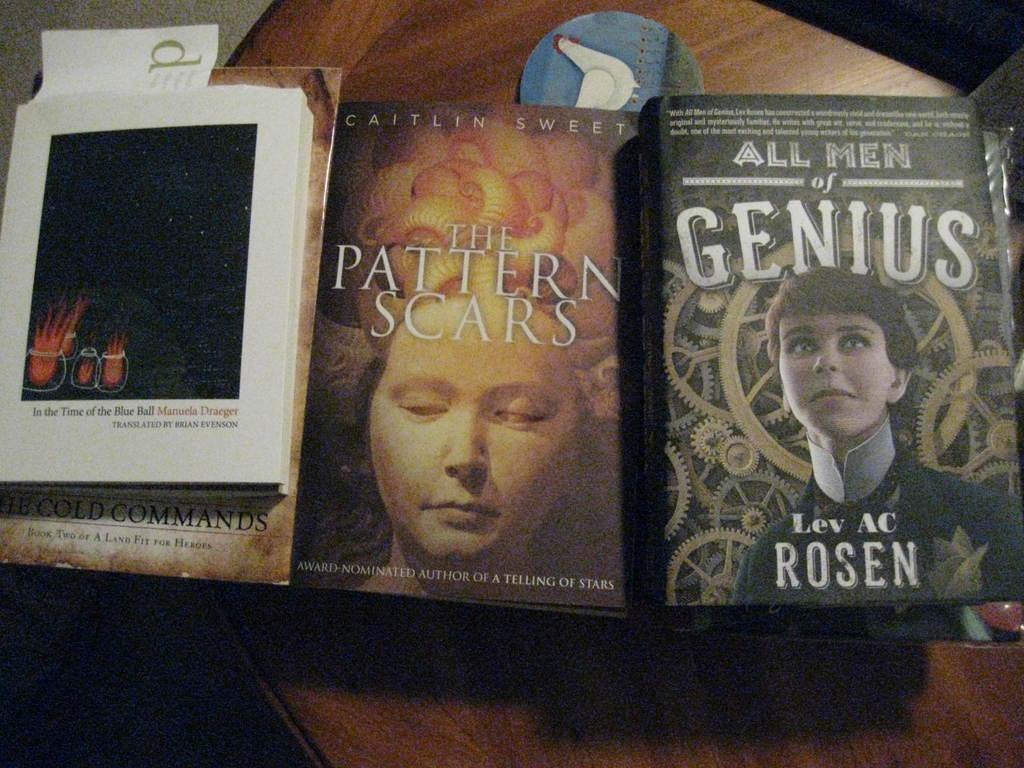Can you describe this image briefly? In this picture there are books, paper, badge placed on a wooden table. 